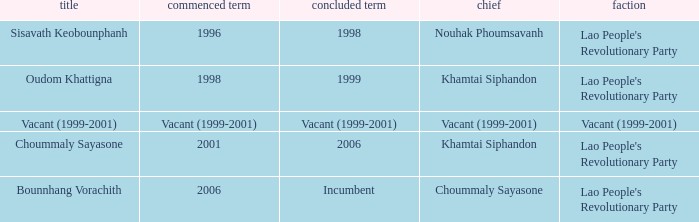What is Left Office, when Took Office is 2006? Incumbent. 